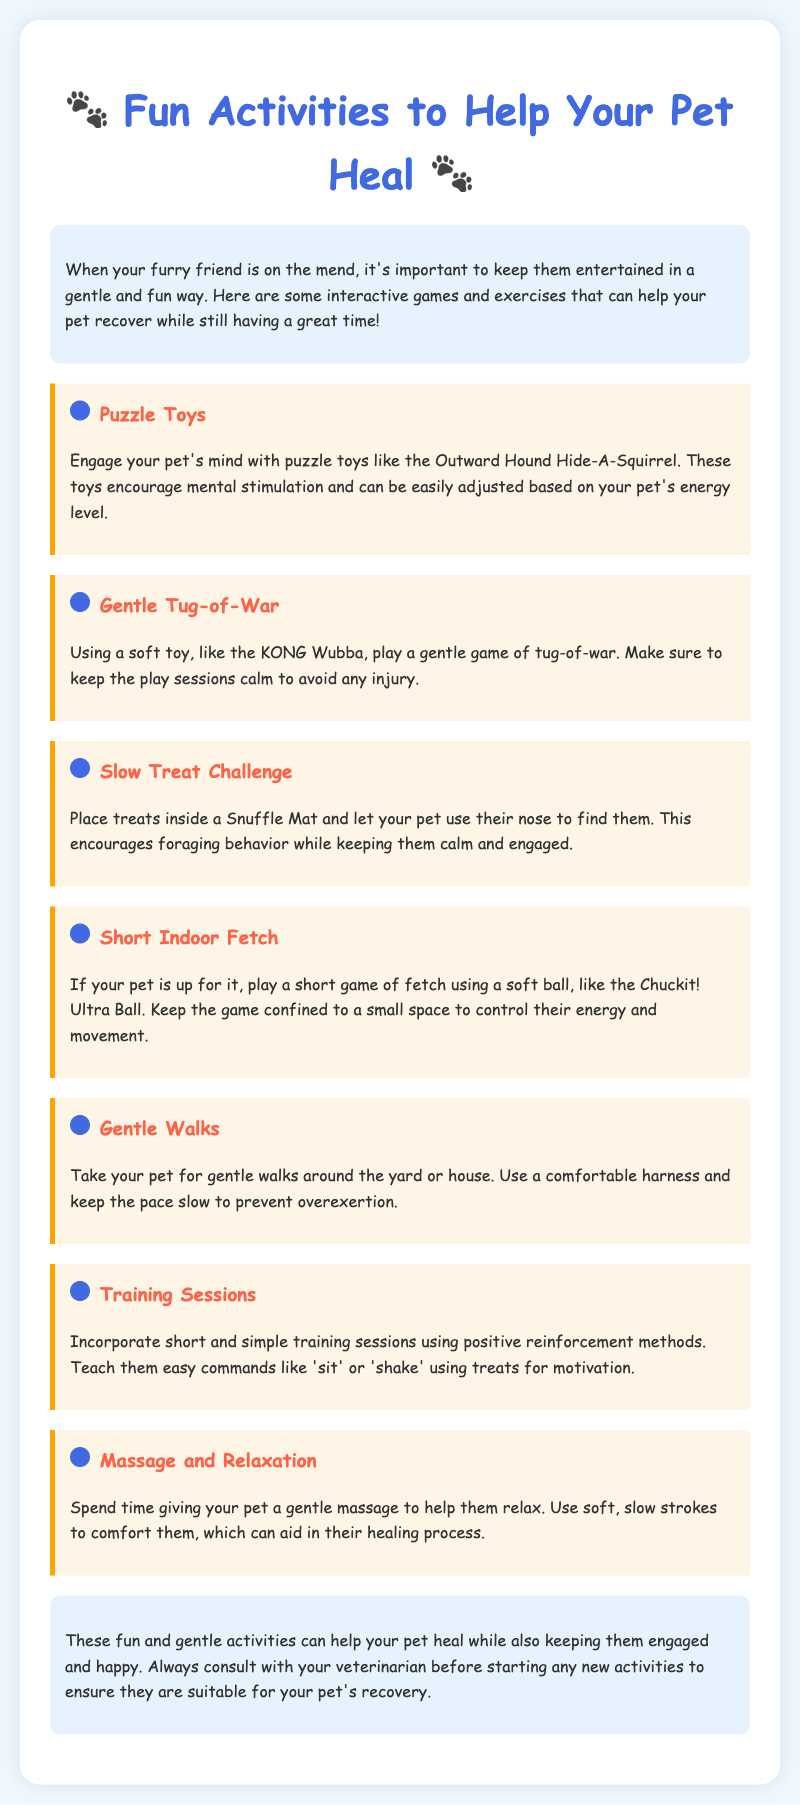What is the title of the document? The title of the document is prominently displayed at the top and indicates the subject matter of the manual.
Answer: Fun Activities to Help Your Pet Heal What is one type of activity suggested for pets? The document lists several activities designed to engage pets during recovery.
Answer: Puzzle Toys What should you avoid during tug-of-war? The document recommends certain precautions when engaging in this activity to ensure safety and comfort.
Answer: Injury What item is mentioned for the Slow Treat Challenge? The activity involves using a specific item to keep pets engaged in a gentle manner.
Answer: Snuffle Mat What is a gentle way to help your pet relax? The document suggests a particular activity that offers comfort and aids in healing.
Answer: Massage How many activities are listed in the document? The total count of activities outlined in the manual can be deduced from the content structured under their respective headings.
Answer: Seven What command can be taught during training sessions? The manual suggests a simple command that can be used as part of training, enhancing the bond with the pet.
Answer: Sit What color is used for the paw-print icons in the document? The color of the paw-print icons is specified in the design of the activities section for a playful touch.
Answer: Blue 